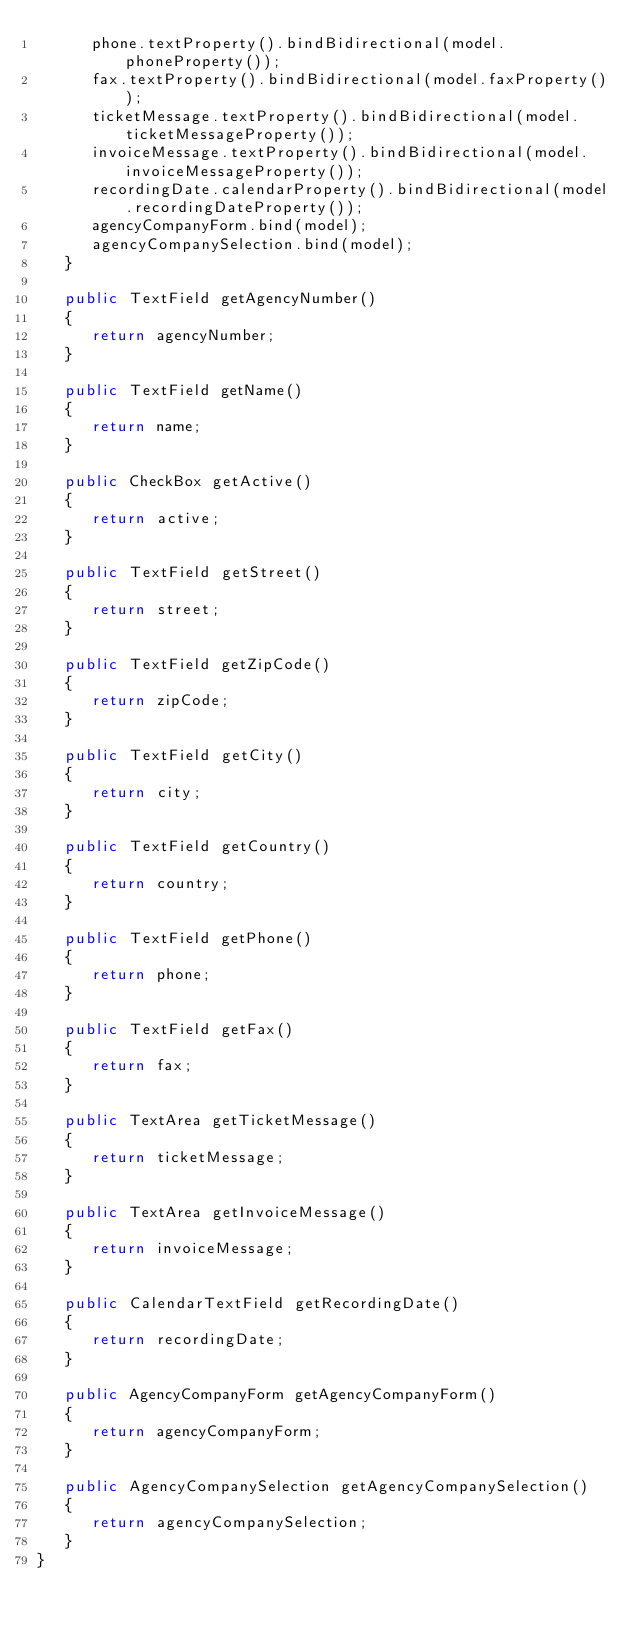<code> <loc_0><loc_0><loc_500><loc_500><_Java_>      phone.textProperty().bindBidirectional(model.phoneProperty());
      fax.textProperty().bindBidirectional(model.faxProperty());
      ticketMessage.textProperty().bindBidirectional(model.ticketMessageProperty());
      invoiceMessage.textProperty().bindBidirectional(model.invoiceMessageProperty());
      recordingDate.calendarProperty().bindBidirectional(model.recordingDateProperty());
      agencyCompanyForm.bind(model);
      agencyCompanySelection.bind(model);
   }

   public TextField getAgencyNumber()
   {
      return agencyNumber;
   }

   public TextField getName()
   {
      return name;
   }

   public CheckBox getActive()
   {
      return active;
   }

   public TextField getStreet()
   {
      return street;
   }

   public TextField getZipCode()
   {
      return zipCode;
   }

   public TextField getCity()
   {
      return city;
   }

   public TextField getCountry()
   {
      return country;
   }

   public TextField getPhone()
   {
      return phone;
   }

   public TextField getFax()
   {
      return fax;
   }

   public TextArea getTicketMessage()
   {
      return ticketMessage;
   }

   public TextArea getInvoiceMessage()
   {
      return invoiceMessage;
   }

   public CalendarTextField getRecordingDate()
   {
      return recordingDate;
   }

   public AgencyCompanyForm getAgencyCompanyForm()
   {
      return agencyCompanyForm;
   }

   public AgencyCompanySelection getAgencyCompanySelection()
   {
      return agencyCompanySelection;
   }
}
</code> 